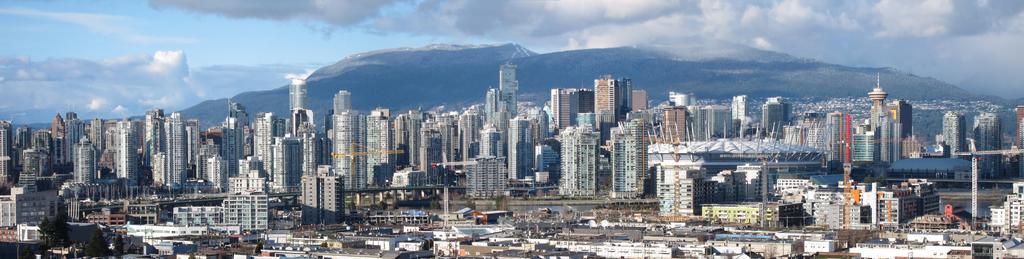In one or two sentences, can you explain what this image depicts? In this image there are buildings, trees, cranes, mountains and water. At the top of the image there are clouds in the sky. 